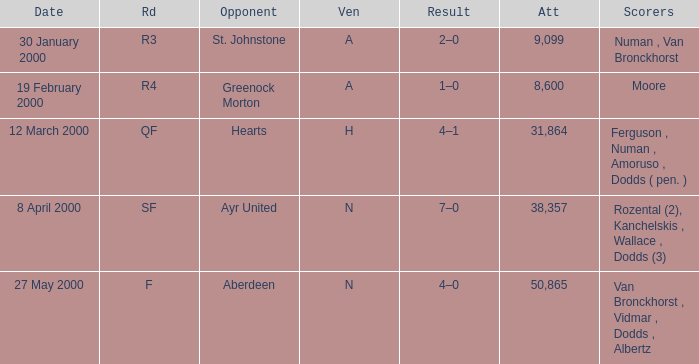Who was in a with opponent St. Johnstone? Numan , Van Bronckhorst. 